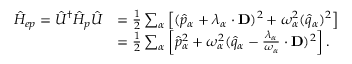<formula> <loc_0><loc_0><loc_500><loc_500>\begin{array} { r l } { \hat { H } _ { e p } = \hat { U } ^ { \dag } \hat { H } _ { p } \hat { U } } & { = \frac { 1 } { 2 } \sum _ { \alpha } \left [ ( \hat { p } _ { \alpha } + \lambda _ { \alpha } \cdot D ) ^ { 2 } + \omega _ { \alpha } ^ { 2 } ( \hat { q } _ { \alpha } ) ^ { 2 } \right ] } \\ & { = \frac { 1 } { 2 } \sum _ { \alpha } \left [ \hat { p } _ { \alpha } ^ { 2 } + \omega _ { \alpha } ^ { 2 } ( \hat { q } _ { \alpha } - \frac { \lambda _ { \alpha } } { \omega _ { \alpha } } \cdot D ) ^ { 2 } \right ] . } \end{array}</formula> 